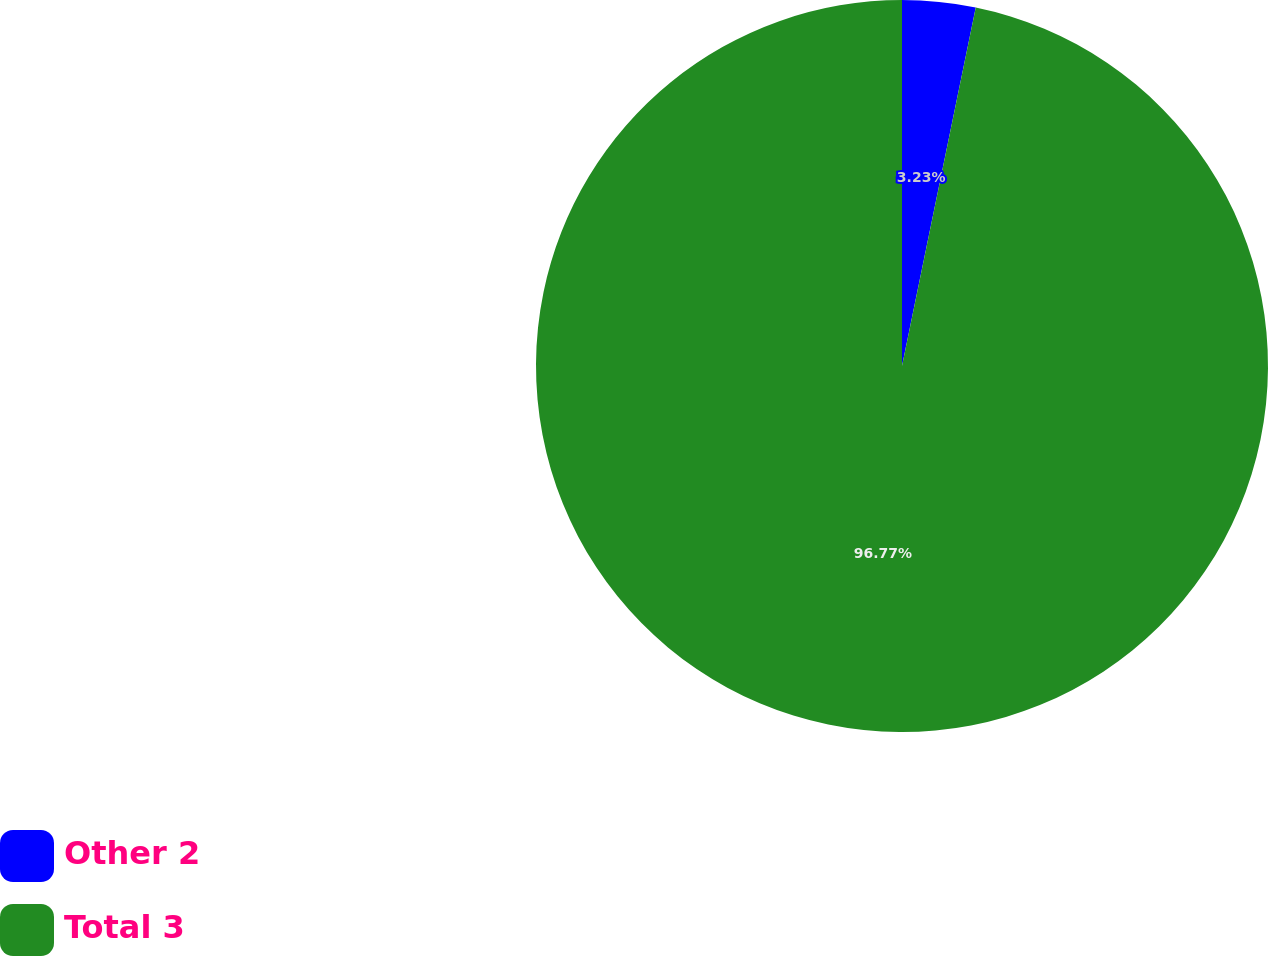Convert chart to OTSL. <chart><loc_0><loc_0><loc_500><loc_500><pie_chart><fcel>Other 2<fcel>Total 3<nl><fcel>3.23%<fcel>96.77%<nl></chart> 